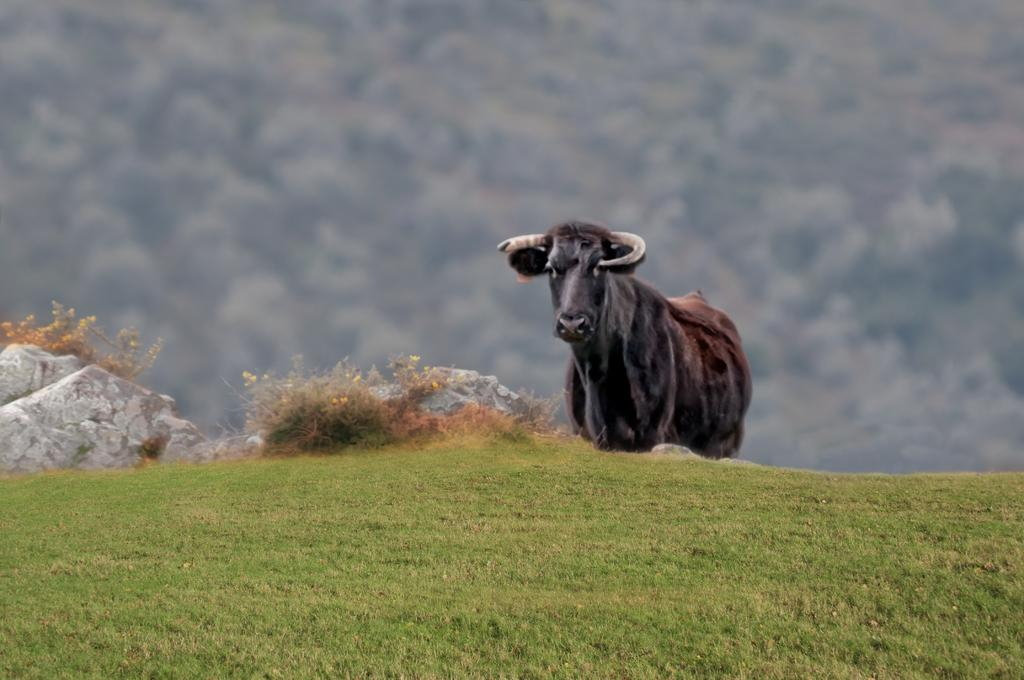What is the main subject in the center of the image? There is an animal in the center of the image. What other elements can be seen in the image besides the animal? There are plants, rocks, and grass visible in the image. How would you describe the background of the image? The background of the image is blurry. What type of lumber is being used to build the dollhouse in the image? There is no dollhouse or lumber present in the image; it features an animal, plants, rocks, and grass. 